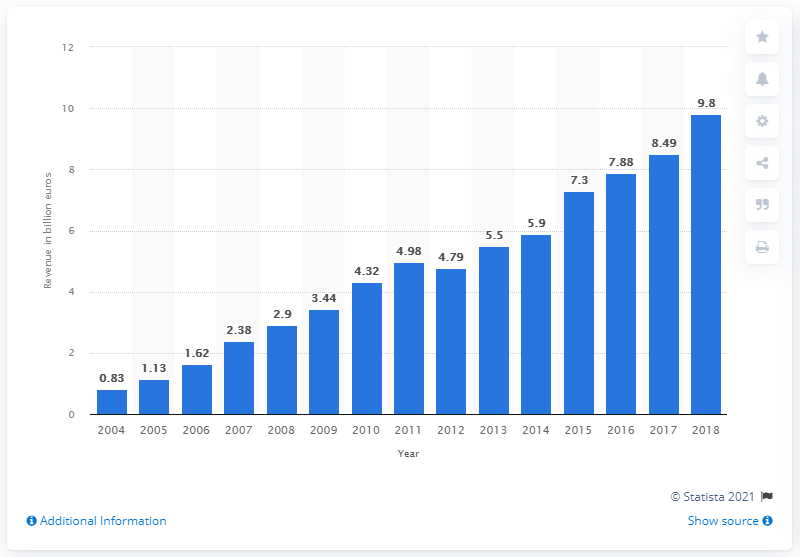Highlight a few significant elements in this photo. In 2018, the revenue generated from Fairtrade International products was 9.8 billion U.S. dollars. 